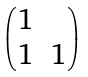Convert formula to latex. <formula><loc_0><loc_0><loc_500><loc_500>\begin{pmatrix} 1 & \\ 1 & 1 \end{pmatrix}</formula> 